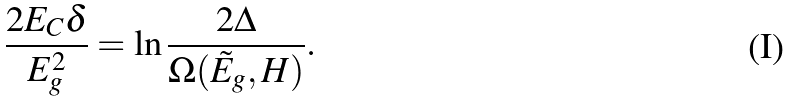Convert formula to latex. <formula><loc_0><loc_0><loc_500><loc_500>\frac { 2 E _ { C } \delta } { E _ { g } ^ { 2 } } = \ln \frac { 2 \Delta } { \Omega ( \tilde { E } _ { g } , H ) } .</formula> 